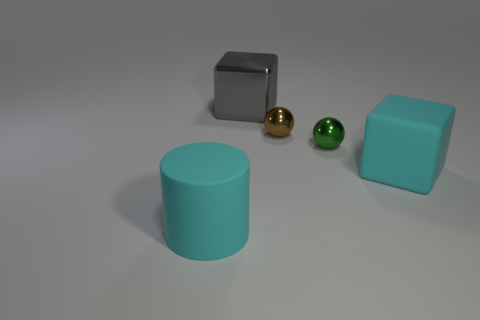What could be the uses of these objects in real-life scenarios? The objects resemble simplistic models of everyday items. The cylinders and cubes might represent containers or packaging, while the spheres could be decorative elements like baubles or bearings in machinery, highlighting the intersection of design and utility. 